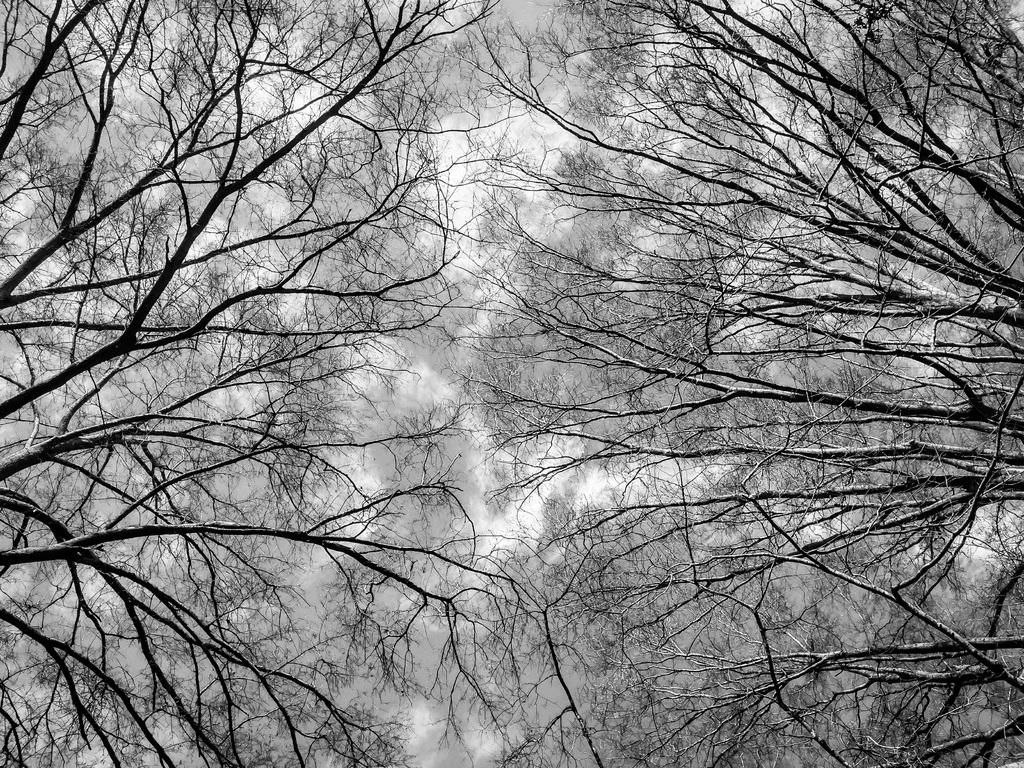What type of vegetation can be seen in the image? There are trees in the image. What type of food is being played on the musical instrument in the image? There is no musical instrument or food present in the image; it only features trees. Can you see any veins in the trees in the image? The image does not show the internal structure of the trees, so it is not possible to determine if any veins are visible. 